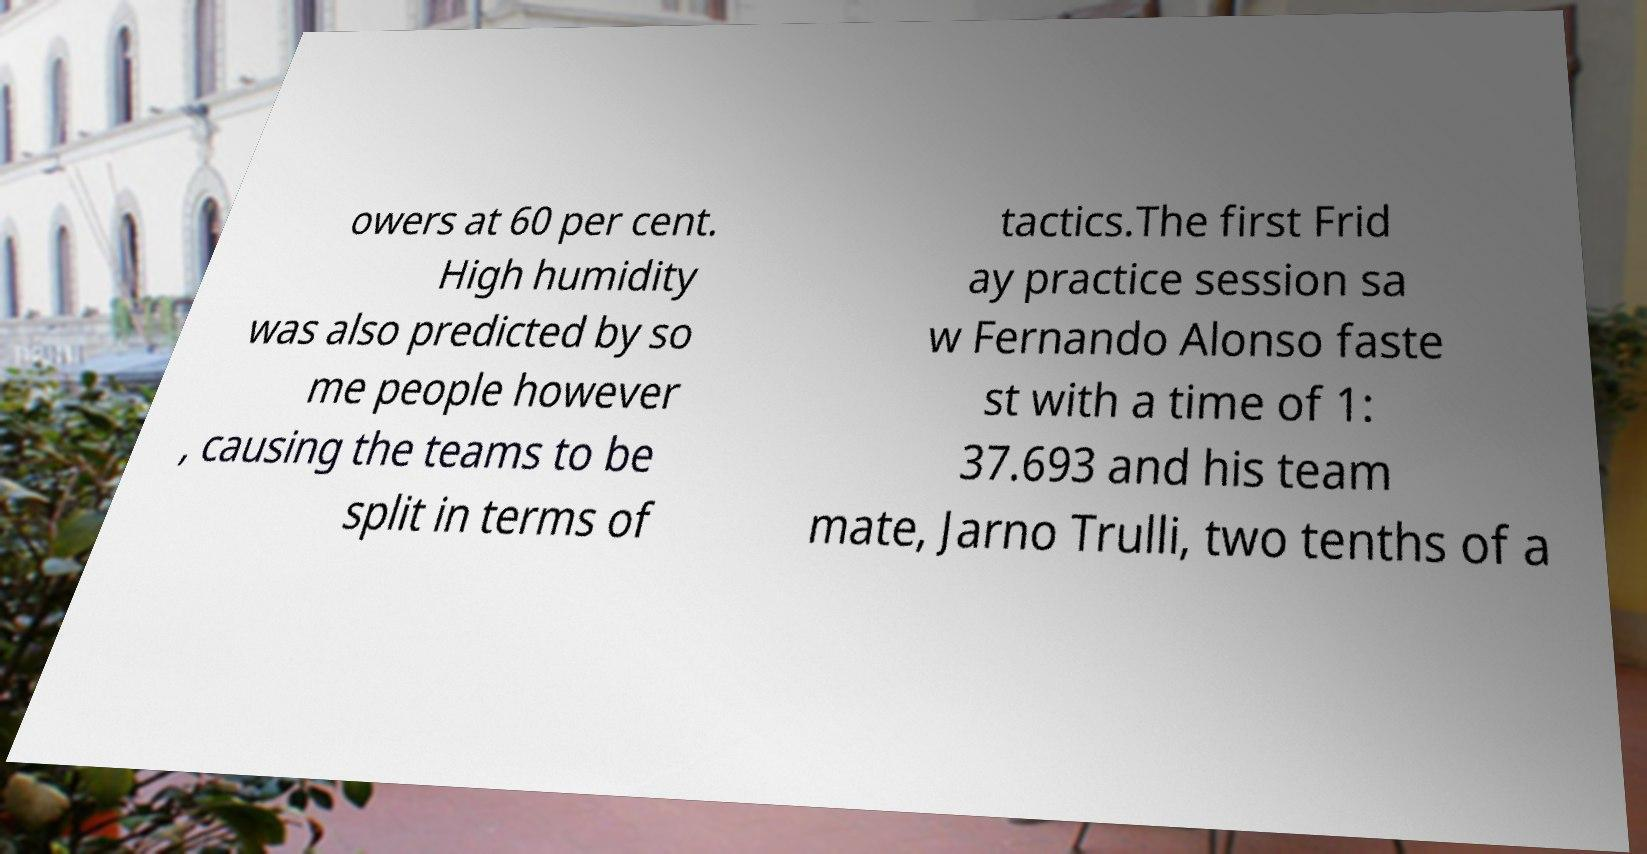Please identify and transcribe the text found in this image. owers at 60 per cent. High humidity was also predicted by so me people however , causing the teams to be split in terms of tactics.The first Frid ay practice session sa w Fernando Alonso faste st with a time of 1: 37.693 and his team mate, Jarno Trulli, two tenths of a 